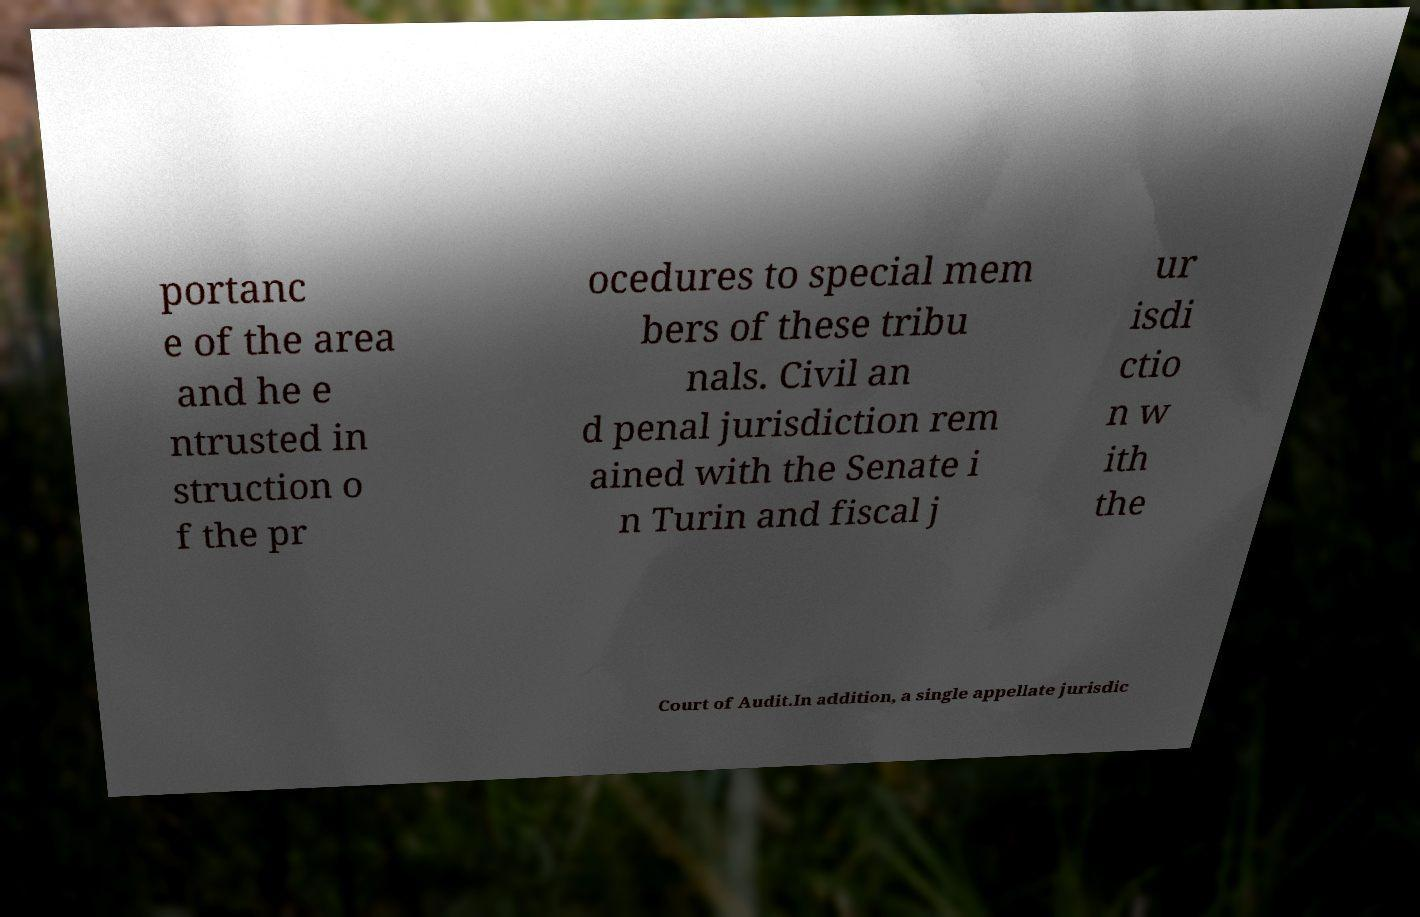Can you accurately transcribe the text from the provided image for me? portanc e of the area and he e ntrusted in struction o f the pr ocedures to special mem bers of these tribu nals. Civil an d penal jurisdiction rem ained with the Senate i n Turin and fiscal j ur isdi ctio n w ith the Court of Audit.In addition, a single appellate jurisdic 